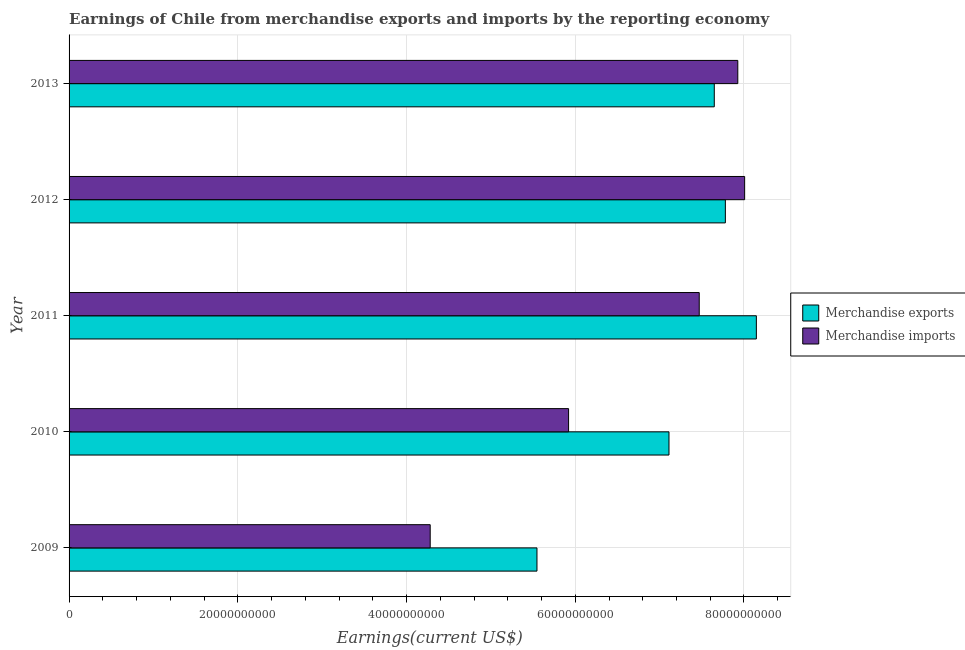How many groups of bars are there?
Your response must be concise. 5. Are the number of bars on each tick of the Y-axis equal?
Your answer should be very brief. Yes. How many bars are there on the 3rd tick from the top?
Provide a succinct answer. 2. How many bars are there on the 1st tick from the bottom?
Ensure brevity in your answer.  2. What is the label of the 4th group of bars from the top?
Make the answer very short. 2010. In how many cases, is the number of bars for a given year not equal to the number of legend labels?
Give a very brief answer. 0. What is the earnings from merchandise imports in 2009?
Your answer should be compact. 4.28e+1. Across all years, what is the maximum earnings from merchandise exports?
Offer a very short reply. 8.15e+1. Across all years, what is the minimum earnings from merchandise exports?
Ensure brevity in your answer.  5.55e+1. What is the total earnings from merchandise imports in the graph?
Your answer should be compact. 3.36e+11. What is the difference between the earnings from merchandise exports in 2009 and that in 2012?
Your answer should be compact. -2.23e+1. What is the difference between the earnings from merchandise exports in 2009 and the earnings from merchandise imports in 2011?
Make the answer very short. -1.92e+1. What is the average earnings from merchandise exports per year?
Your answer should be very brief. 7.25e+1. In the year 2009, what is the difference between the earnings from merchandise exports and earnings from merchandise imports?
Provide a succinct answer. 1.27e+1. What is the ratio of the earnings from merchandise imports in 2010 to that in 2012?
Your response must be concise. 0.74. Is the earnings from merchandise imports in 2009 less than that in 2010?
Ensure brevity in your answer.  Yes. What is the difference between the highest and the second highest earnings from merchandise imports?
Your answer should be compact. 8.13e+08. What is the difference between the highest and the lowest earnings from merchandise imports?
Ensure brevity in your answer.  3.73e+1. In how many years, is the earnings from merchandise imports greater than the average earnings from merchandise imports taken over all years?
Offer a very short reply. 3. What is the difference between two consecutive major ticks on the X-axis?
Keep it short and to the point. 2.00e+1. Does the graph contain grids?
Ensure brevity in your answer.  Yes. Where does the legend appear in the graph?
Your response must be concise. Center right. What is the title of the graph?
Make the answer very short. Earnings of Chile from merchandise exports and imports by the reporting economy. What is the label or title of the X-axis?
Your answer should be very brief. Earnings(current US$). What is the label or title of the Y-axis?
Give a very brief answer. Year. What is the Earnings(current US$) of Merchandise exports in 2009?
Provide a short and direct response. 5.55e+1. What is the Earnings(current US$) in Merchandise imports in 2009?
Provide a short and direct response. 4.28e+1. What is the Earnings(current US$) in Merchandise exports in 2010?
Your response must be concise. 7.11e+1. What is the Earnings(current US$) of Merchandise imports in 2010?
Make the answer very short. 5.92e+1. What is the Earnings(current US$) in Merchandise exports in 2011?
Your response must be concise. 8.15e+1. What is the Earnings(current US$) of Merchandise imports in 2011?
Your response must be concise. 7.47e+1. What is the Earnings(current US$) in Merchandise exports in 2012?
Provide a succinct answer. 7.78e+1. What is the Earnings(current US$) in Merchandise imports in 2012?
Your response must be concise. 8.01e+1. What is the Earnings(current US$) in Merchandise exports in 2013?
Your answer should be very brief. 7.65e+1. What is the Earnings(current US$) in Merchandise imports in 2013?
Your response must be concise. 7.93e+1. Across all years, what is the maximum Earnings(current US$) in Merchandise exports?
Give a very brief answer. 8.15e+1. Across all years, what is the maximum Earnings(current US$) of Merchandise imports?
Ensure brevity in your answer.  8.01e+1. Across all years, what is the minimum Earnings(current US$) of Merchandise exports?
Your answer should be very brief. 5.55e+1. Across all years, what is the minimum Earnings(current US$) of Merchandise imports?
Provide a succinct answer. 4.28e+1. What is the total Earnings(current US$) in Merchandise exports in the graph?
Offer a terse response. 3.62e+11. What is the total Earnings(current US$) of Merchandise imports in the graph?
Ensure brevity in your answer.  3.36e+11. What is the difference between the Earnings(current US$) in Merchandise exports in 2009 and that in 2010?
Keep it short and to the point. -1.56e+1. What is the difference between the Earnings(current US$) of Merchandise imports in 2009 and that in 2010?
Your answer should be compact. -1.64e+1. What is the difference between the Earnings(current US$) in Merchandise exports in 2009 and that in 2011?
Provide a succinct answer. -2.60e+1. What is the difference between the Earnings(current US$) in Merchandise imports in 2009 and that in 2011?
Offer a terse response. -3.19e+1. What is the difference between the Earnings(current US$) of Merchandise exports in 2009 and that in 2012?
Your response must be concise. -2.23e+1. What is the difference between the Earnings(current US$) in Merchandise imports in 2009 and that in 2012?
Give a very brief answer. -3.73e+1. What is the difference between the Earnings(current US$) in Merchandise exports in 2009 and that in 2013?
Offer a terse response. -2.10e+1. What is the difference between the Earnings(current US$) of Merchandise imports in 2009 and that in 2013?
Provide a short and direct response. -3.65e+1. What is the difference between the Earnings(current US$) of Merchandise exports in 2010 and that in 2011?
Provide a short and direct response. -1.04e+1. What is the difference between the Earnings(current US$) in Merchandise imports in 2010 and that in 2011?
Provide a short and direct response. -1.55e+1. What is the difference between the Earnings(current US$) in Merchandise exports in 2010 and that in 2012?
Ensure brevity in your answer.  -6.68e+09. What is the difference between the Earnings(current US$) of Merchandise imports in 2010 and that in 2012?
Provide a succinct answer. -2.09e+1. What is the difference between the Earnings(current US$) of Merchandise exports in 2010 and that in 2013?
Provide a succinct answer. -5.37e+09. What is the difference between the Earnings(current US$) in Merchandise imports in 2010 and that in 2013?
Make the answer very short. -2.01e+1. What is the difference between the Earnings(current US$) in Merchandise exports in 2011 and that in 2012?
Provide a succinct answer. 3.68e+09. What is the difference between the Earnings(current US$) of Merchandise imports in 2011 and that in 2012?
Your response must be concise. -5.38e+09. What is the difference between the Earnings(current US$) of Merchandise exports in 2011 and that in 2013?
Give a very brief answer. 4.99e+09. What is the difference between the Earnings(current US$) in Merchandise imports in 2011 and that in 2013?
Give a very brief answer. -4.57e+09. What is the difference between the Earnings(current US$) of Merchandise exports in 2012 and that in 2013?
Offer a terse response. 1.31e+09. What is the difference between the Earnings(current US$) of Merchandise imports in 2012 and that in 2013?
Provide a succinct answer. 8.13e+08. What is the difference between the Earnings(current US$) in Merchandise exports in 2009 and the Earnings(current US$) in Merchandise imports in 2010?
Provide a succinct answer. -3.75e+09. What is the difference between the Earnings(current US$) in Merchandise exports in 2009 and the Earnings(current US$) in Merchandise imports in 2011?
Provide a short and direct response. -1.92e+1. What is the difference between the Earnings(current US$) in Merchandise exports in 2009 and the Earnings(current US$) in Merchandise imports in 2012?
Give a very brief answer. -2.46e+1. What is the difference between the Earnings(current US$) of Merchandise exports in 2009 and the Earnings(current US$) of Merchandise imports in 2013?
Keep it short and to the point. -2.38e+1. What is the difference between the Earnings(current US$) of Merchandise exports in 2010 and the Earnings(current US$) of Merchandise imports in 2011?
Provide a short and direct response. -3.59e+09. What is the difference between the Earnings(current US$) in Merchandise exports in 2010 and the Earnings(current US$) in Merchandise imports in 2012?
Provide a succinct answer. -8.97e+09. What is the difference between the Earnings(current US$) in Merchandise exports in 2010 and the Earnings(current US$) in Merchandise imports in 2013?
Make the answer very short. -8.16e+09. What is the difference between the Earnings(current US$) in Merchandise exports in 2011 and the Earnings(current US$) in Merchandise imports in 2012?
Your response must be concise. 1.39e+09. What is the difference between the Earnings(current US$) of Merchandise exports in 2011 and the Earnings(current US$) of Merchandise imports in 2013?
Give a very brief answer. 2.20e+09. What is the difference between the Earnings(current US$) of Merchandise exports in 2012 and the Earnings(current US$) of Merchandise imports in 2013?
Give a very brief answer. -1.47e+09. What is the average Earnings(current US$) of Merchandise exports per year?
Your response must be concise. 7.25e+1. What is the average Earnings(current US$) in Merchandise imports per year?
Your answer should be very brief. 6.72e+1. In the year 2009, what is the difference between the Earnings(current US$) of Merchandise exports and Earnings(current US$) of Merchandise imports?
Provide a short and direct response. 1.27e+1. In the year 2010, what is the difference between the Earnings(current US$) in Merchandise exports and Earnings(current US$) in Merchandise imports?
Keep it short and to the point. 1.19e+1. In the year 2011, what is the difference between the Earnings(current US$) in Merchandise exports and Earnings(current US$) in Merchandise imports?
Your answer should be compact. 6.77e+09. In the year 2012, what is the difference between the Earnings(current US$) in Merchandise exports and Earnings(current US$) in Merchandise imports?
Your answer should be very brief. -2.29e+09. In the year 2013, what is the difference between the Earnings(current US$) in Merchandise exports and Earnings(current US$) in Merchandise imports?
Your answer should be compact. -2.79e+09. What is the ratio of the Earnings(current US$) in Merchandise exports in 2009 to that in 2010?
Ensure brevity in your answer.  0.78. What is the ratio of the Earnings(current US$) in Merchandise imports in 2009 to that in 2010?
Keep it short and to the point. 0.72. What is the ratio of the Earnings(current US$) in Merchandise exports in 2009 to that in 2011?
Your answer should be very brief. 0.68. What is the ratio of the Earnings(current US$) of Merchandise imports in 2009 to that in 2011?
Offer a very short reply. 0.57. What is the ratio of the Earnings(current US$) of Merchandise exports in 2009 to that in 2012?
Your answer should be very brief. 0.71. What is the ratio of the Earnings(current US$) of Merchandise imports in 2009 to that in 2012?
Your answer should be very brief. 0.53. What is the ratio of the Earnings(current US$) in Merchandise exports in 2009 to that in 2013?
Ensure brevity in your answer.  0.73. What is the ratio of the Earnings(current US$) of Merchandise imports in 2009 to that in 2013?
Your answer should be very brief. 0.54. What is the ratio of the Earnings(current US$) in Merchandise exports in 2010 to that in 2011?
Make the answer very short. 0.87. What is the ratio of the Earnings(current US$) of Merchandise imports in 2010 to that in 2011?
Ensure brevity in your answer.  0.79. What is the ratio of the Earnings(current US$) in Merchandise exports in 2010 to that in 2012?
Make the answer very short. 0.91. What is the ratio of the Earnings(current US$) in Merchandise imports in 2010 to that in 2012?
Make the answer very short. 0.74. What is the ratio of the Earnings(current US$) of Merchandise exports in 2010 to that in 2013?
Offer a terse response. 0.93. What is the ratio of the Earnings(current US$) of Merchandise imports in 2010 to that in 2013?
Keep it short and to the point. 0.75. What is the ratio of the Earnings(current US$) of Merchandise exports in 2011 to that in 2012?
Provide a short and direct response. 1.05. What is the ratio of the Earnings(current US$) in Merchandise imports in 2011 to that in 2012?
Provide a short and direct response. 0.93. What is the ratio of the Earnings(current US$) in Merchandise exports in 2011 to that in 2013?
Make the answer very short. 1.07. What is the ratio of the Earnings(current US$) in Merchandise imports in 2011 to that in 2013?
Your answer should be compact. 0.94. What is the ratio of the Earnings(current US$) in Merchandise exports in 2012 to that in 2013?
Ensure brevity in your answer.  1.02. What is the ratio of the Earnings(current US$) in Merchandise imports in 2012 to that in 2013?
Your response must be concise. 1.01. What is the difference between the highest and the second highest Earnings(current US$) of Merchandise exports?
Your answer should be very brief. 3.68e+09. What is the difference between the highest and the second highest Earnings(current US$) of Merchandise imports?
Ensure brevity in your answer.  8.13e+08. What is the difference between the highest and the lowest Earnings(current US$) in Merchandise exports?
Keep it short and to the point. 2.60e+1. What is the difference between the highest and the lowest Earnings(current US$) in Merchandise imports?
Offer a terse response. 3.73e+1. 